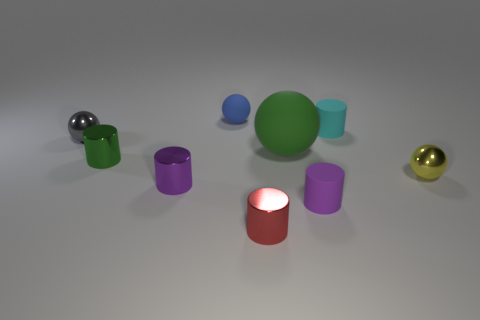Subtract 1 balls. How many balls are left? 3 Subtract all red cylinders. How many cylinders are left? 4 Subtract all red metallic cylinders. How many cylinders are left? 4 Subtract all gray cylinders. Subtract all brown spheres. How many cylinders are left? 5 Add 1 big shiny balls. How many objects exist? 10 Subtract all spheres. How many objects are left? 5 Add 8 tiny gray rubber objects. How many tiny gray rubber objects exist? 8 Subtract 1 blue spheres. How many objects are left? 8 Subtract all small brown metallic cylinders. Subtract all cyan matte things. How many objects are left? 8 Add 5 large green balls. How many large green balls are left? 6 